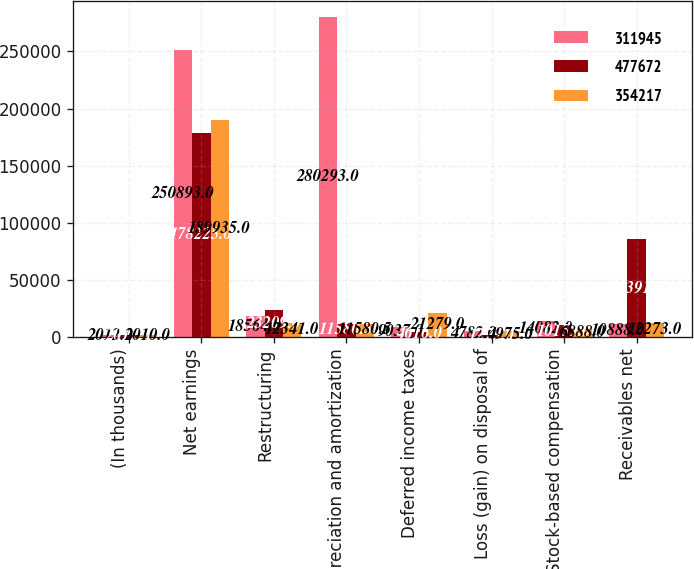Convert chart to OTSL. <chart><loc_0><loc_0><loc_500><loc_500><stacked_bar_chart><ecel><fcel>(In thousands)<fcel>Net earnings<fcel>Restructuring<fcel>Depreciation and amortization<fcel>Deferred income taxes<fcel>Loss (gain) on disposal of<fcel>Stock-based compensation<fcel>Receivables net<nl><fcel>311945<fcel>2012<fcel>250893<fcel>18564<fcel>280293<fcel>9037<fcel>4782<fcel>14082<fcel>10888<nl><fcel>477672<fcel>2011<fcel>178225<fcel>23209<fcel>11580.5<fcel>4616<fcel>1273<fcel>10159<fcel>85391<nl><fcel>354217<fcel>2010<fcel>189935<fcel>12341<fcel>11580.5<fcel>21279<fcel>4975<fcel>6888<fcel>12273<nl></chart> 